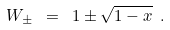<formula> <loc_0><loc_0><loc_500><loc_500>W _ { \pm } \ = \ 1 \pm \sqrt { 1 - x } \ .</formula> 